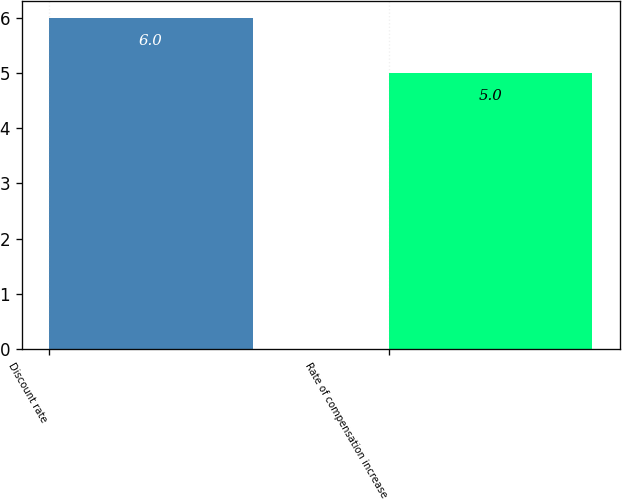<chart> <loc_0><loc_0><loc_500><loc_500><bar_chart><fcel>Discount rate<fcel>Rate of compensation increase<nl><fcel>6<fcel>5<nl></chart> 